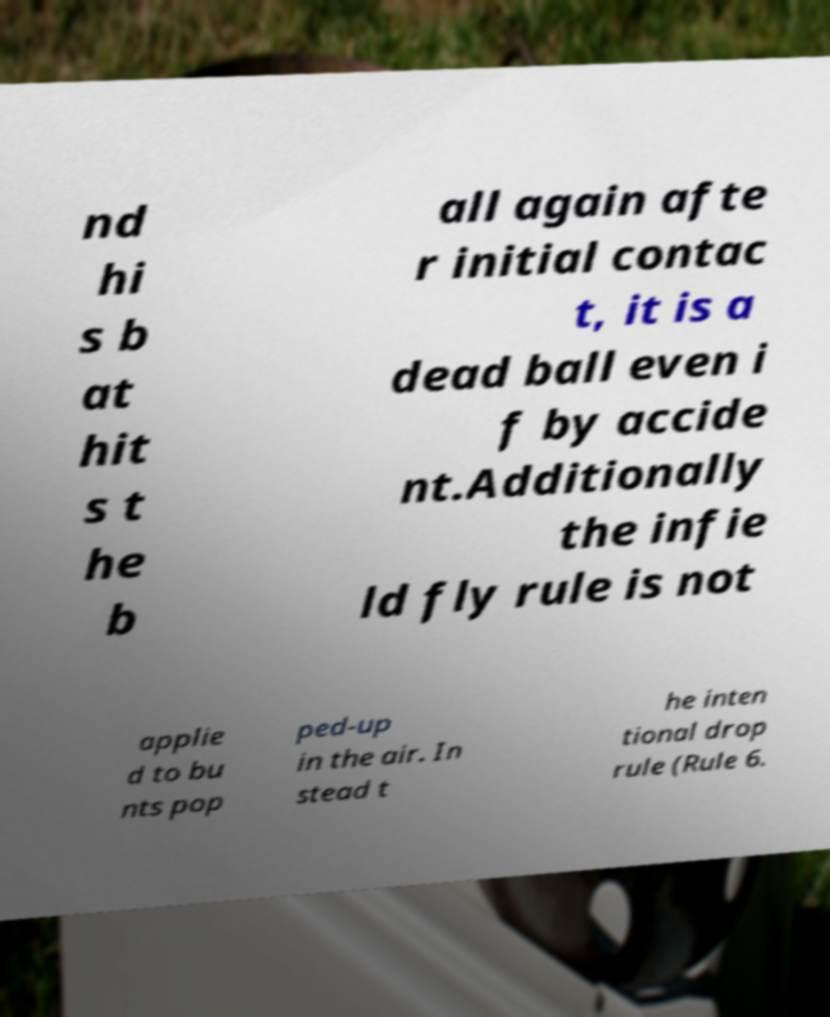What messages or text are displayed in this image? I need them in a readable, typed format. nd hi s b at hit s t he b all again afte r initial contac t, it is a dead ball even i f by accide nt.Additionally the infie ld fly rule is not applie d to bu nts pop ped-up in the air. In stead t he inten tional drop rule (Rule 6. 